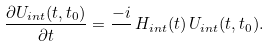Convert formula to latex. <formula><loc_0><loc_0><loc_500><loc_500>\frac { \partial U _ { i n t } ( t , t _ { 0 } ) } { \partial t } = \frac { - i } { } \, H _ { i n t } ( t ) \, U _ { i n t } ( t , t _ { 0 } ) .</formula> 